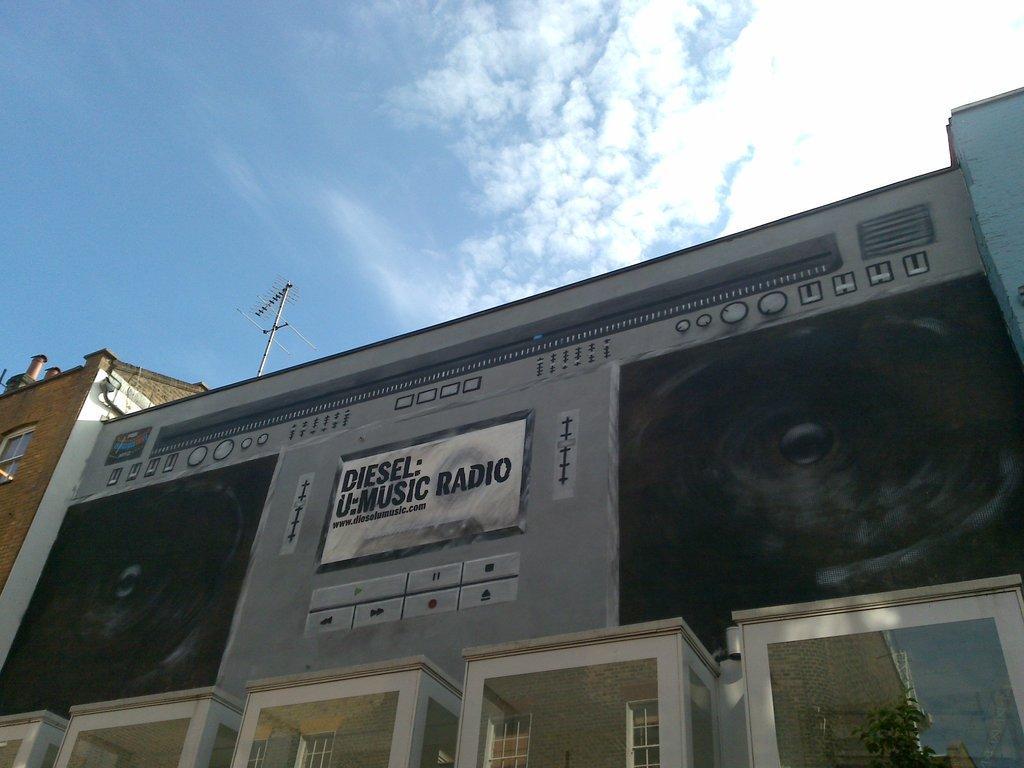Can you describe this image briefly? In this image there are buildings and we can see boards placed on the buildings. In the background there is sky. 